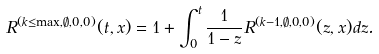Convert formula to latex. <formula><loc_0><loc_0><loc_500><loc_500>R ^ { ( k \leq \max , \emptyset , 0 , 0 ) } ( t , x ) = 1 + \int _ { 0 } ^ { t } \frac { 1 } { 1 - z } R ^ { ( k - 1 , \emptyset , 0 , 0 ) } ( z , x ) d z .</formula> 